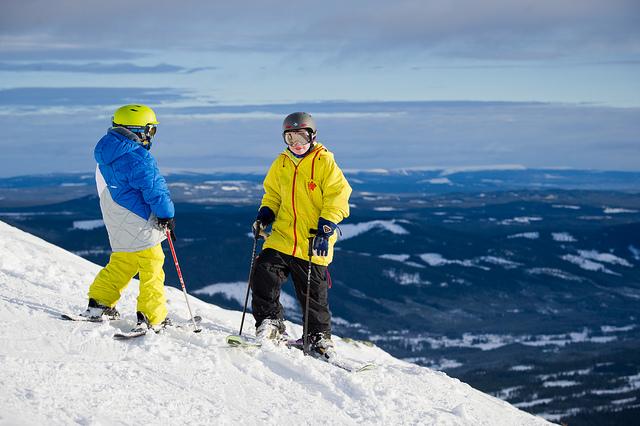Does it look cold?
Write a very short answer. Yes. How high are they?
Write a very short answer. Very. What can you see in the boy's goggles?
Keep it brief. Reflection. 